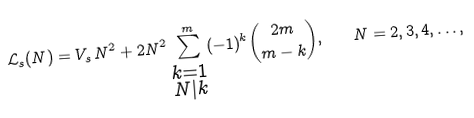Convert formula to latex. <formula><loc_0><loc_0><loc_500><loc_500>\mathcal { L } _ { s } ( N ) = V _ { s } \, N ^ { 2 } + 2 N ^ { 2 } \sum _ { \substack { k = 1 \\ N | k } } ^ { m } ( - 1 ) ^ { k } \binom { 2 m } { m - k } , \quad N = 2 , 3 , 4 , \dots ,</formula> 